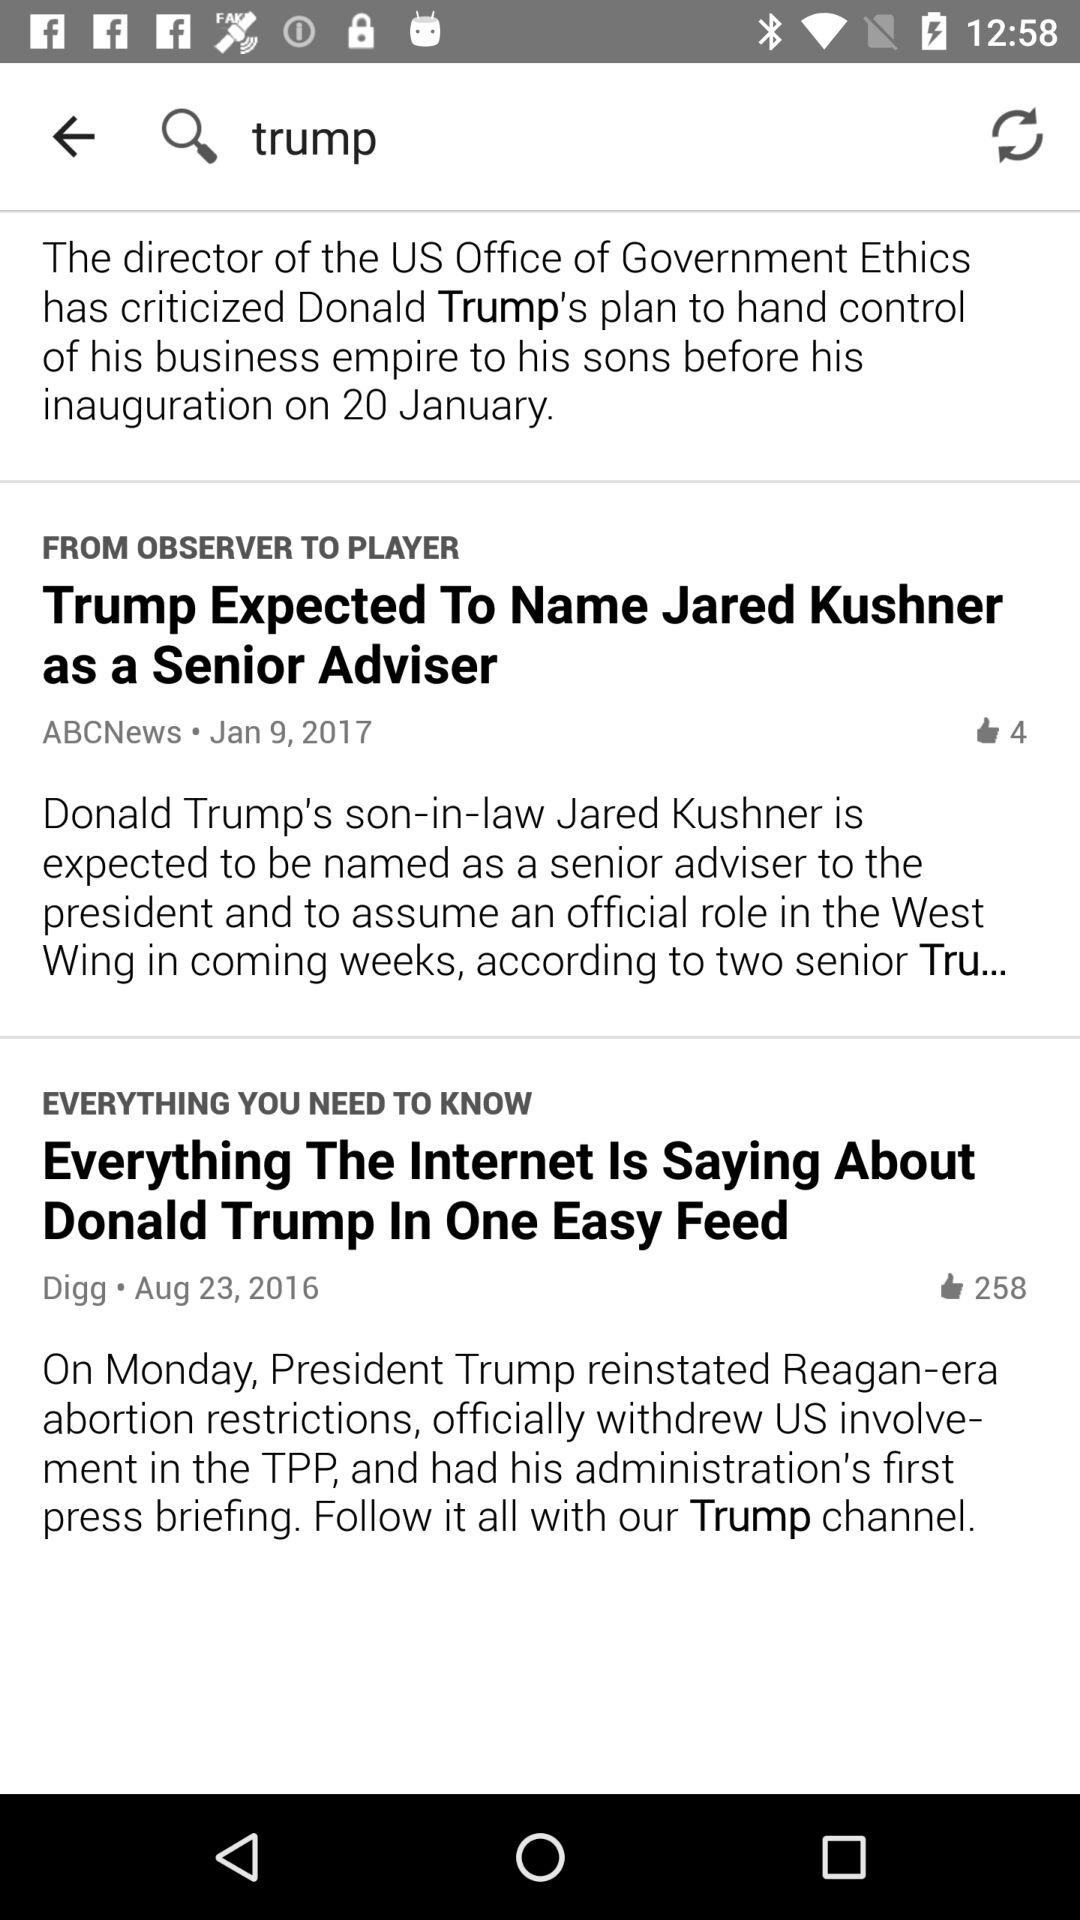How many likes are there on "ABCNews"? There are 4 likes. 